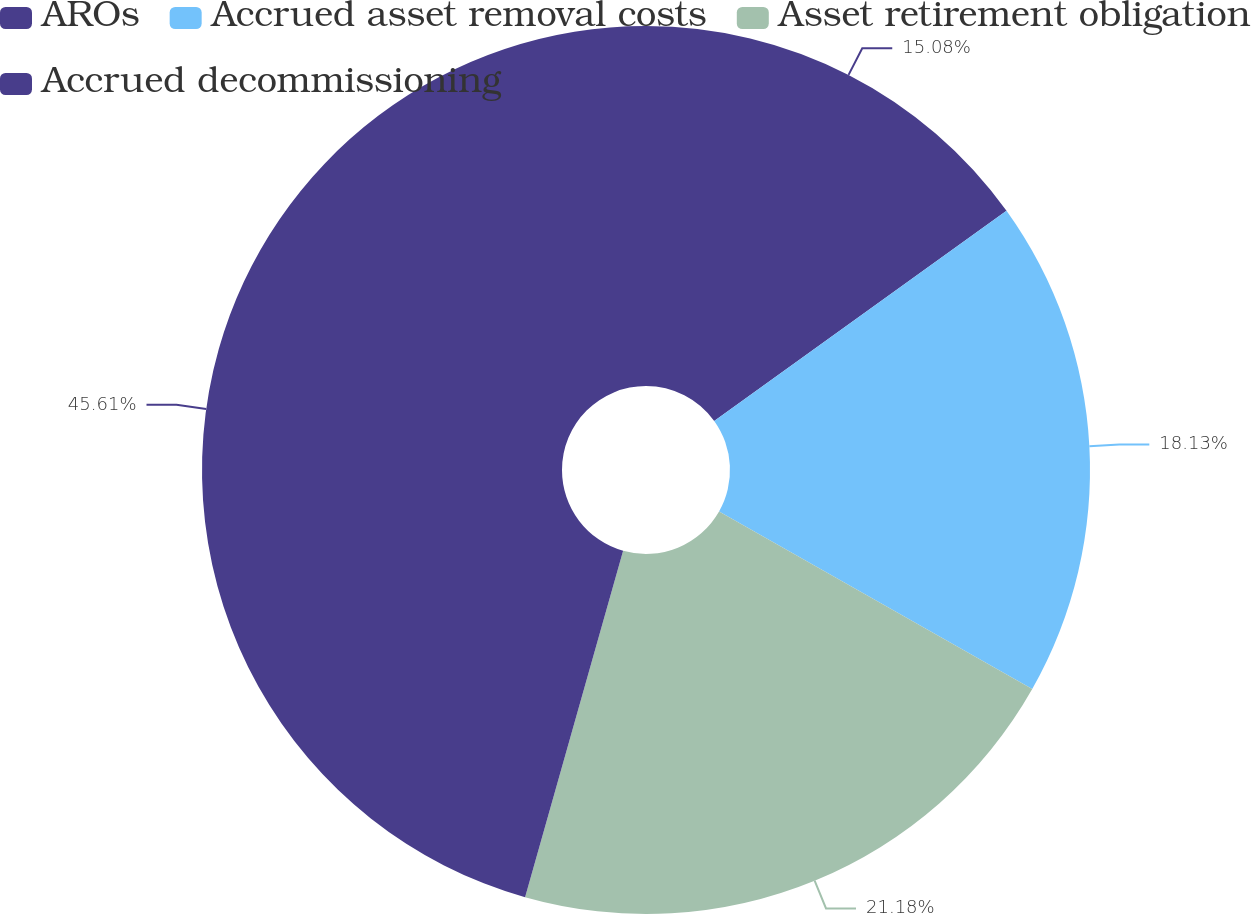Convert chart. <chart><loc_0><loc_0><loc_500><loc_500><pie_chart><fcel>AROs<fcel>Accrued asset removal costs<fcel>Asset retirement obligation<fcel>Accrued decommissioning<nl><fcel>15.08%<fcel>18.13%<fcel>21.18%<fcel>45.61%<nl></chart> 